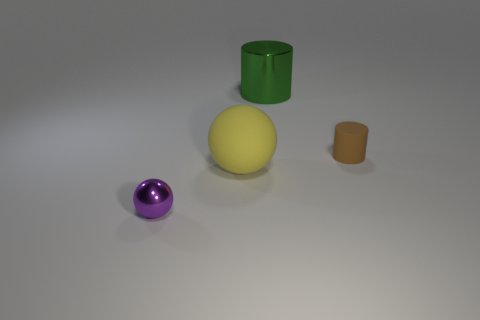The brown object has what shape? cylinder 